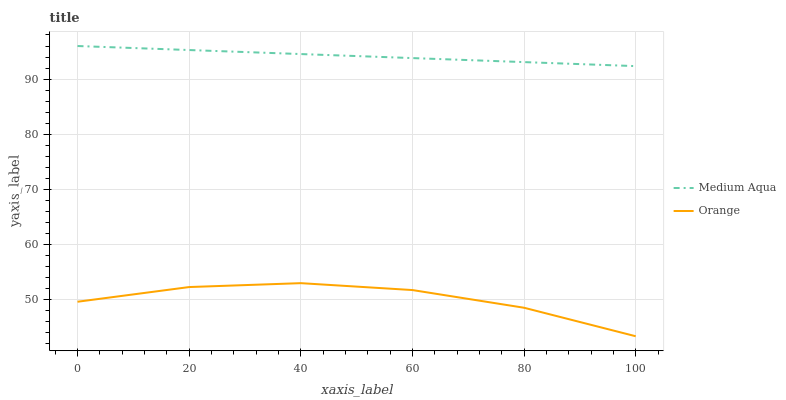Does Orange have the minimum area under the curve?
Answer yes or no. Yes. Does Medium Aqua have the maximum area under the curve?
Answer yes or no. Yes. Does Medium Aqua have the minimum area under the curve?
Answer yes or no. No. Is Medium Aqua the smoothest?
Answer yes or no. Yes. Is Orange the roughest?
Answer yes or no. Yes. Is Medium Aqua the roughest?
Answer yes or no. No. Does Orange have the lowest value?
Answer yes or no. Yes. Does Medium Aqua have the lowest value?
Answer yes or no. No. Does Medium Aqua have the highest value?
Answer yes or no. Yes. Is Orange less than Medium Aqua?
Answer yes or no. Yes. Is Medium Aqua greater than Orange?
Answer yes or no. Yes. Does Orange intersect Medium Aqua?
Answer yes or no. No. 